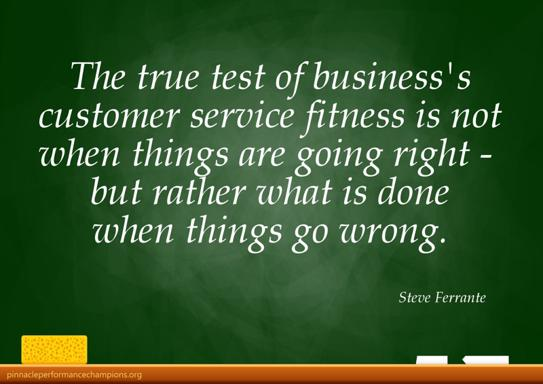Can you explain how the green background of the chalkboard might affect the viewer's perception of the quote? The green background of the chalkboard, often associated with growth and balance, subtly complements the message of the quote. It may invoke a sense of progress and harmony, reinforcing the idea that businesses should evolve and continuously improve their customer service, especially in handling difficulties. 